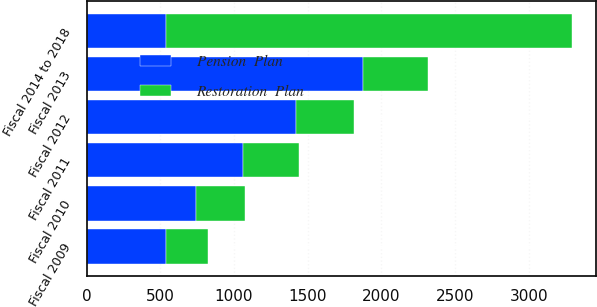<chart> <loc_0><loc_0><loc_500><loc_500><stacked_bar_chart><ecel><fcel>Fiscal 2009<fcel>Fiscal 2010<fcel>Fiscal 2011<fcel>Fiscal 2012<fcel>Fiscal 2013<fcel>Fiscal 2014 to 2018<nl><fcel>Pension  Plan<fcel>540<fcel>740<fcel>1063<fcel>1417<fcel>1872<fcel>540<nl><fcel>Restoration  Plan<fcel>283<fcel>336<fcel>375<fcel>397<fcel>446<fcel>2749<nl></chart> 